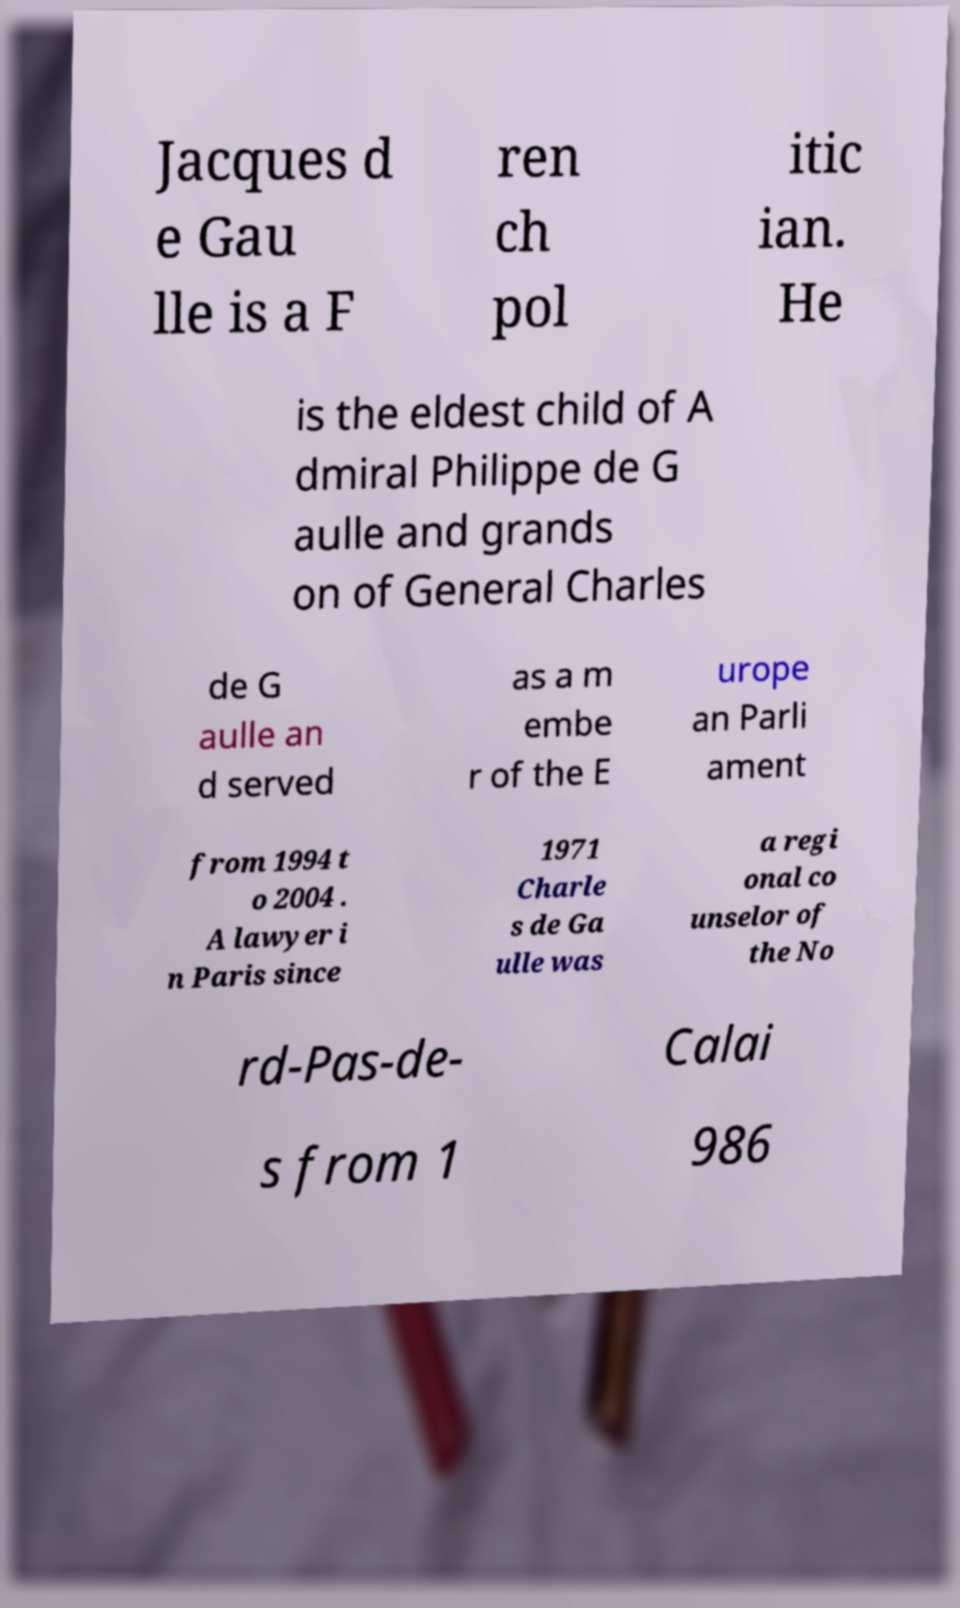Can you accurately transcribe the text from the provided image for me? Jacques d e Gau lle is a F ren ch pol itic ian. He is the eldest child of A dmiral Philippe de G aulle and grands on of General Charles de G aulle an d served as a m embe r of the E urope an Parli ament from 1994 t o 2004 . A lawyer i n Paris since 1971 Charle s de Ga ulle was a regi onal co unselor of the No rd-Pas-de- Calai s from 1 986 